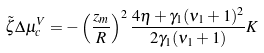<formula> <loc_0><loc_0><loc_500><loc_500>\tilde { \zeta } \Delta \mu _ { c } ^ { V } = - \left ( \frac { z _ { m } } { R } \right ) ^ { 2 } \frac { 4 \eta + \gamma _ { 1 } ( \nu _ { 1 } + 1 ) ^ { 2 } } { 2 \gamma _ { 1 } ( \nu _ { 1 } + 1 ) } K</formula> 